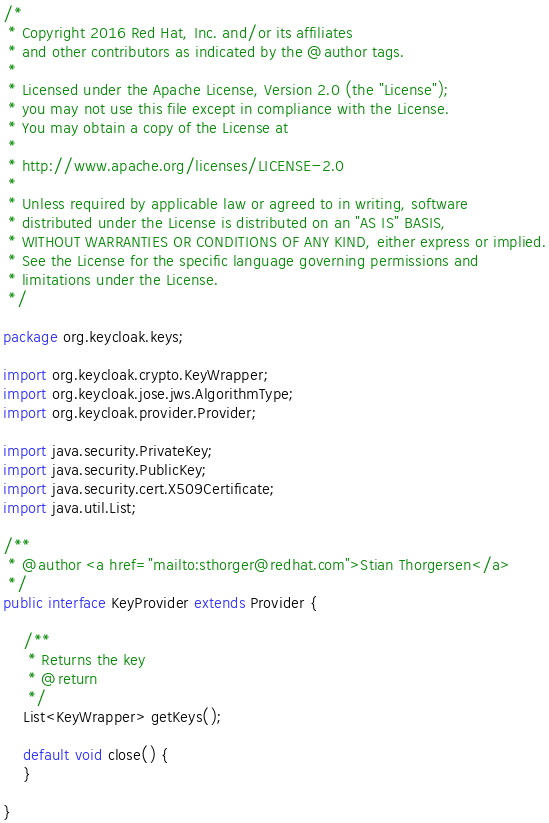Convert code to text. <code><loc_0><loc_0><loc_500><loc_500><_Java_>/*
 * Copyright 2016 Red Hat, Inc. and/or its affiliates
 * and other contributors as indicated by the @author tags.
 *
 * Licensed under the Apache License, Version 2.0 (the "License");
 * you may not use this file except in compliance with the License.
 * You may obtain a copy of the License at
 *
 * http://www.apache.org/licenses/LICENSE-2.0
 *
 * Unless required by applicable law or agreed to in writing, software
 * distributed under the License is distributed on an "AS IS" BASIS,
 * WITHOUT WARRANTIES OR CONDITIONS OF ANY KIND, either express or implied.
 * See the License for the specific language governing permissions and
 * limitations under the License.
 */

package org.keycloak.keys;

import org.keycloak.crypto.KeyWrapper;
import org.keycloak.jose.jws.AlgorithmType;
import org.keycloak.provider.Provider;

import java.security.PrivateKey;
import java.security.PublicKey;
import java.security.cert.X509Certificate;
import java.util.List;

/**
 * @author <a href="mailto:sthorger@redhat.com">Stian Thorgersen</a>
 */
public interface KeyProvider extends Provider {

    /**
     * Returns the key
     * @return
     */
    List<KeyWrapper> getKeys();

    default void close() {
    }

}
</code> 